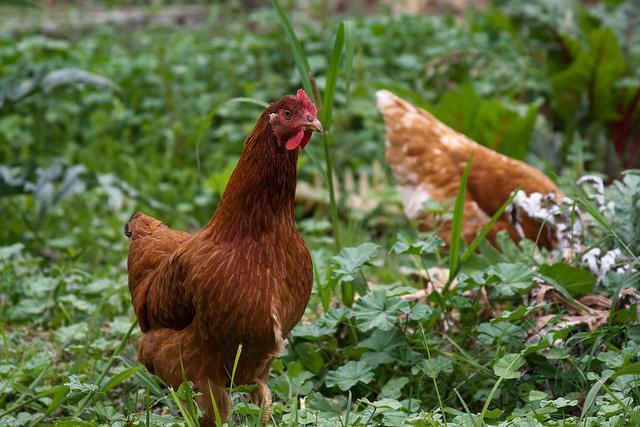How many chickens?
Give a very brief answer. 2. How many birds are in the photo?
Give a very brief answer. 2. 